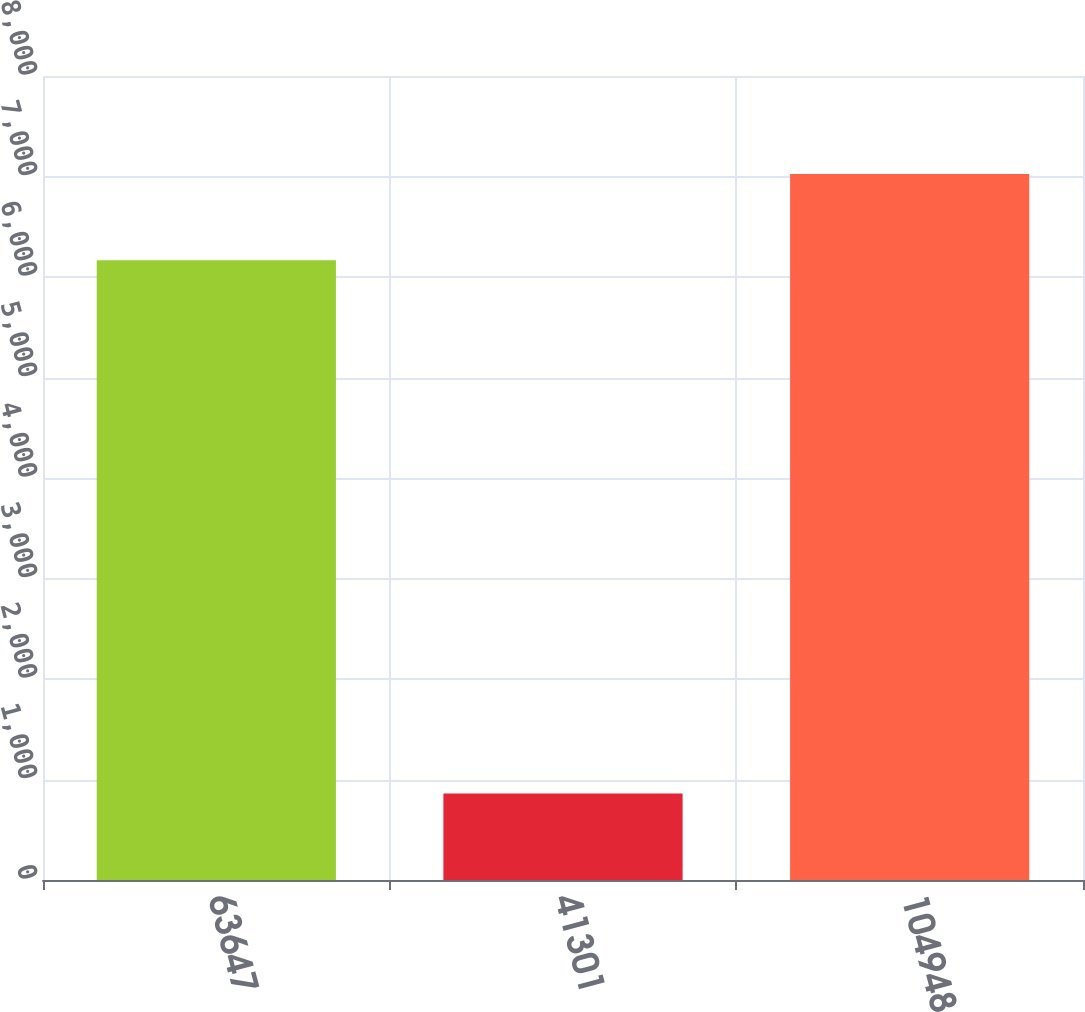<chart> <loc_0><loc_0><loc_500><loc_500><bar_chart><fcel>63647<fcel>41301<fcel>104948<nl><fcel>6166<fcel>860<fcel>7026<nl></chart> 